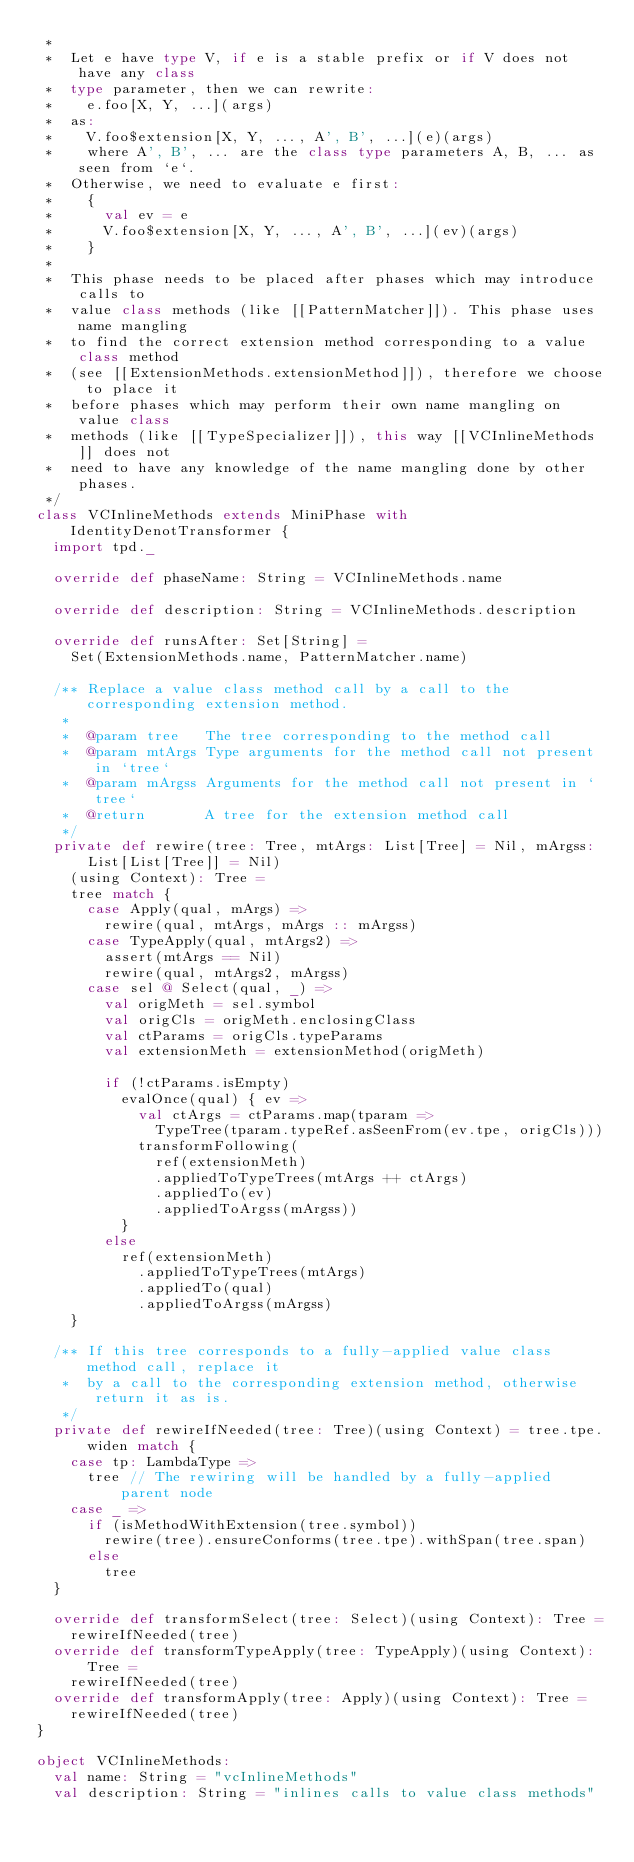<code> <loc_0><loc_0><loc_500><loc_500><_Scala_> *
 *  Let e have type V, if e is a stable prefix or if V does not have any class
 *  type parameter, then we can rewrite:
 *    e.foo[X, Y, ...](args)
 *  as:
 *    V.foo$extension[X, Y, ..., A', B', ...](e)(args)
 *    where A', B', ... are the class type parameters A, B, ... as seen from `e`.
 *  Otherwise, we need to evaluate e first:
 *    {
 *      val ev = e
 *      V.foo$extension[X, Y, ..., A', B', ...](ev)(args)
 *    }
 *
 *  This phase needs to be placed after phases which may introduce calls to
 *  value class methods (like [[PatternMatcher]]). This phase uses name mangling
 *  to find the correct extension method corresponding to a value class method
 *  (see [[ExtensionMethods.extensionMethod]]), therefore we choose to place it
 *  before phases which may perform their own name mangling on value class
 *  methods (like [[TypeSpecializer]]), this way [[VCInlineMethods]] does not
 *  need to have any knowledge of the name mangling done by other phases.
 */
class VCInlineMethods extends MiniPhase with IdentityDenotTransformer {
  import tpd._

  override def phaseName: String = VCInlineMethods.name

  override def description: String = VCInlineMethods.description

  override def runsAfter: Set[String] =
    Set(ExtensionMethods.name, PatternMatcher.name)

  /** Replace a value class method call by a call to the corresponding extension method.
   *
   *  @param tree   The tree corresponding to the method call
   *  @param mtArgs Type arguments for the method call not present in `tree`
   *  @param mArgss Arguments for the method call not present in `tree`
   *  @return       A tree for the extension method call
   */
  private def rewire(tree: Tree, mtArgs: List[Tree] = Nil, mArgss: List[List[Tree]] = Nil)
    (using Context): Tree =
    tree match {
      case Apply(qual, mArgs) =>
        rewire(qual, mtArgs, mArgs :: mArgss)
      case TypeApply(qual, mtArgs2) =>
        assert(mtArgs == Nil)
        rewire(qual, mtArgs2, mArgss)
      case sel @ Select(qual, _) =>
        val origMeth = sel.symbol
        val origCls = origMeth.enclosingClass
        val ctParams = origCls.typeParams
        val extensionMeth = extensionMethod(origMeth)

        if (!ctParams.isEmpty)
          evalOnce(qual) { ev =>
            val ctArgs = ctParams.map(tparam =>
              TypeTree(tparam.typeRef.asSeenFrom(ev.tpe, origCls)))
            transformFollowing(
              ref(extensionMeth)
              .appliedToTypeTrees(mtArgs ++ ctArgs)
              .appliedTo(ev)
              .appliedToArgss(mArgss))
          }
        else
          ref(extensionMeth)
            .appliedToTypeTrees(mtArgs)
            .appliedTo(qual)
            .appliedToArgss(mArgss)
    }

  /** If this tree corresponds to a fully-applied value class method call, replace it
   *  by a call to the corresponding extension method, otherwise return it as is.
   */
  private def rewireIfNeeded(tree: Tree)(using Context) = tree.tpe.widen match {
    case tp: LambdaType =>
      tree // The rewiring will be handled by a fully-applied parent node
    case _ =>
      if (isMethodWithExtension(tree.symbol))
        rewire(tree).ensureConforms(tree.tpe).withSpan(tree.span)
      else
        tree
  }

  override def transformSelect(tree: Select)(using Context): Tree =
    rewireIfNeeded(tree)
  override def transformTypeApply(tree: TypeApply)(using Context): Tree =
    rewireIfNeeded(tree)
  override def transformApply(tree: Apply)(using Context): Tree =
    rewireIfNeeded(tree)
}

object VCInlineMethods:
  val name: String = "vcInlineMethods"
  val description: String = "inlines calls to value class methods"
</code> 